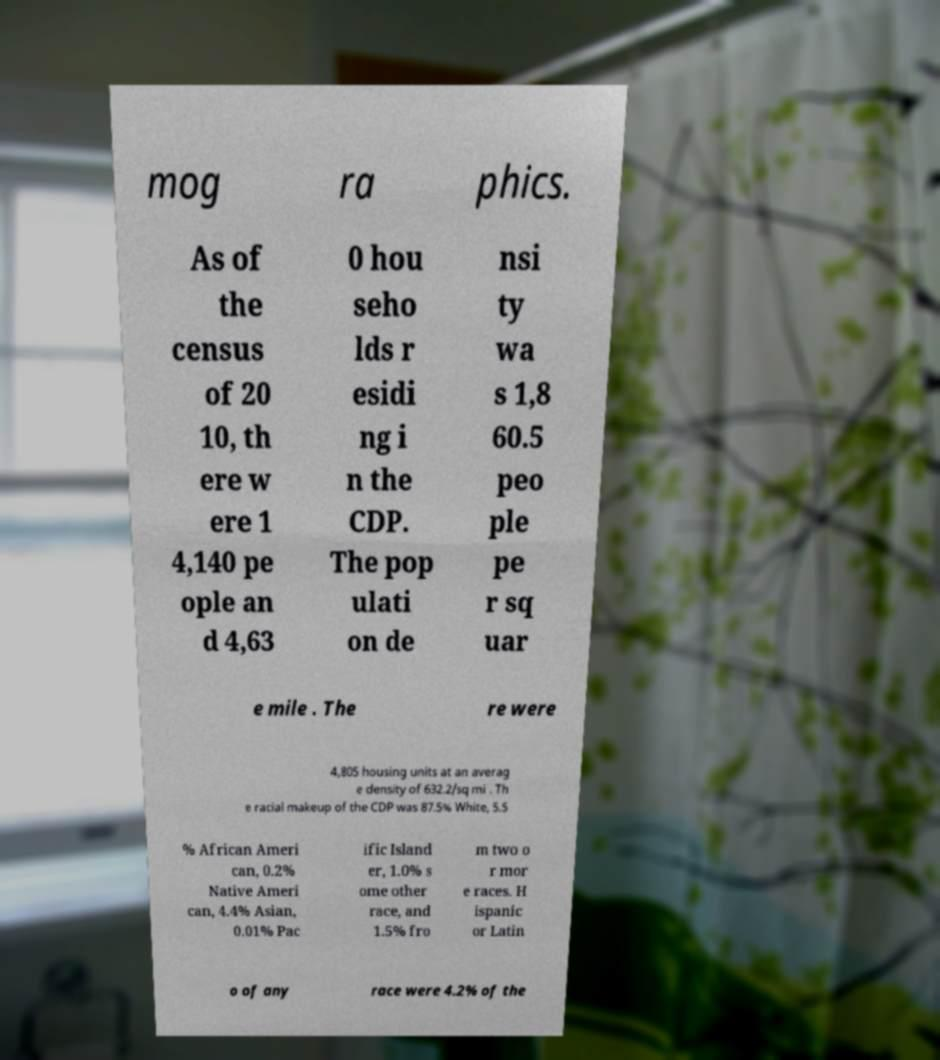Please identify and transcribe the text found in this image. mog ra phics. As of the census of 20 10, th ere w ere 1 4,140 pe ople an d 4,63 0 hou seho lds r esidi ng i n the CDP. The pop ulati on de nsi ty wa s 1,8 60.5 peo ple pe r sq uar e mile . The re were 4,805 housing units at an averag e density of 632.2/sq mi . Th e racial makeup of the CDP was 87.5% White, 5.5 % African Ameri can, 0.2% Native Ameri can, 4.4% Asian, 0.01% Pac ific Island er, 1.0% s ome other race, and 1.5% fro m two o r mor e races. H ispanic or Latin o of any race were 4.2% of the 